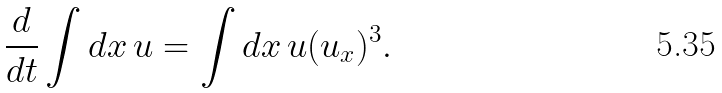<formula> <loc_0><loc_0><loc_500><loc_500>\frac { d } { d t } \int d x \, u = \int d x \, u ( u _ { x } ) ^ { 3 } .</formula> 